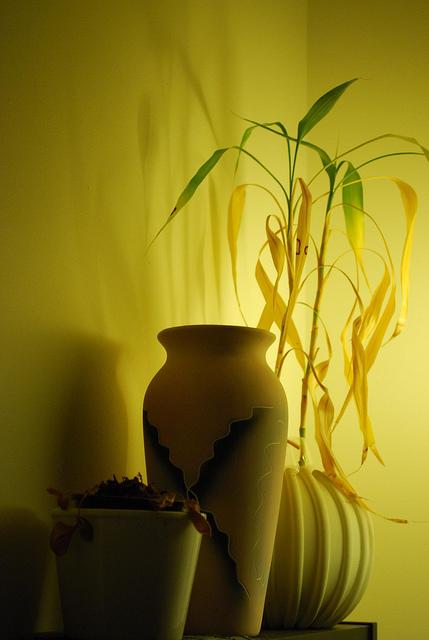What color is the wall?
Short answer required. Yellow. What is in the vase?
Be succinct. Plant. What kind of plant is this?
Write a very short answer. Weeds. What is the main color?
Keep it brief. Yellow. Are there dead leaves on the plant?
Write a very short answer. Yes. What kind of flower is the yellow one?
Short answer required. Lily. Does the center vase have flowers?
Answer briefly. No. Is the vase empty?
Concise answer only. Yes. Do these flowers look healthy?
Give a very brief answer. No. 